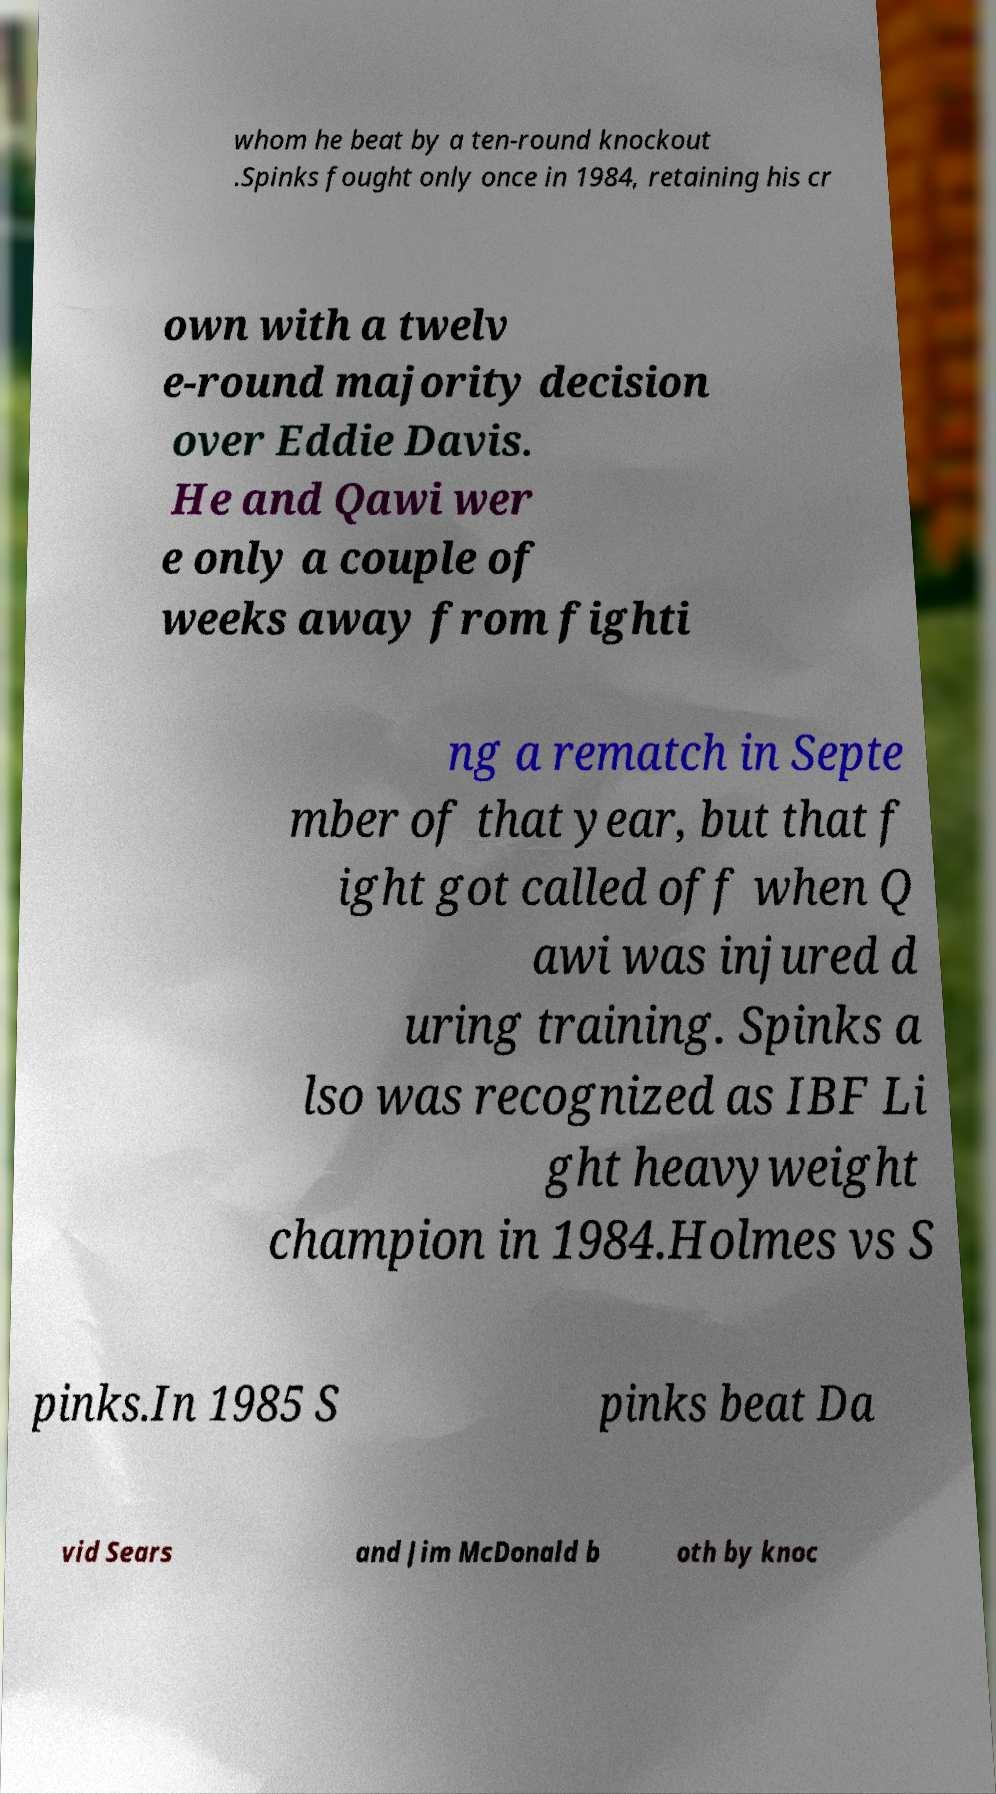Can you read and provide the text displayed in the image?This photo seems to have some interesting text. Can you extract and type it out for me? whom he beat by a ten-round knockout .Spinks fought only once in 1984, retaining his cr own with a twelv e-round majority decision over Eddie Davis. He and Qawi wer e only a couple of weeks away from fighti ng a rematch in Septe mber of that year, but that f ight got called off when Q awi was injured d uring training. Spinks a lso was recognized as IBF Li ght heavyweight champion in 1984.Holmes vs S pinks.In 1985 S pinks beat Da vid Sears and Jim McDonald b oth by knoc 